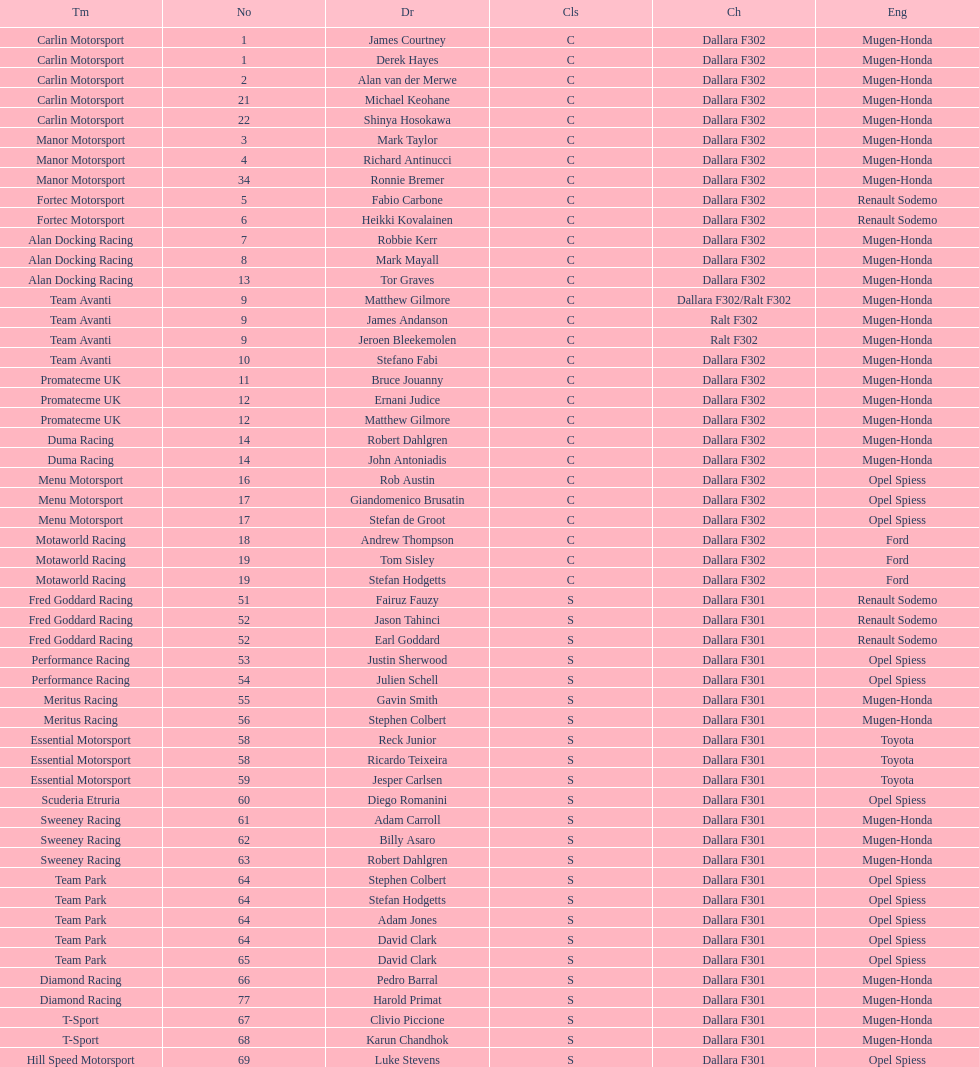Would you mind parsing the complete table? {'header': ['Tm', 'No', 'Dr', 'Cls', 'Ch', 'Eng'], 'rows': [['Carlin Motorsport', '1', 'James Courtney', 'C', 'Dallara F302', 'Mugen-Honda'], ['Carlin Motorsport', '1', 'Derek Hayes', 'C', 'Dallara F302', 'Mugen-Honda'], ['Carlin Motorsport', '2', 'Alan van der Merwe', 'C', 'Dallara F302', 'Mugen-Honda'], ['Carlin Motorsport', '21', 'Michael Keohane', 'C', 'Dallara F302', 'Mugen-Honda'], ['Carlin Motorsport', '22', 'Shinya Hosokawa', 'C', 'Dallara F302', 'Mugen-Honda'], ['Manor Motorsport', '3', 'Mark Taylor', 'C', 'Dallara F302', 'Mugen-Honda'], ['Manor Motorsport', '4', 'Richard Antinucci', 'C', 'Dallara F302', 'Mugen-Honda'], ['Manor Motorsport', '34', 'Ronnie Bremer', 'C', 'Dallara F302', 'Mugen-Honda'], ['Fortec Motorsport', '5', 'Fabio Carbone', 'C', 'Dallara F302', 'Renault Sodemo'], ['Fortec Motorsport', '6', 'Heikki Kovalainen', 'C', 'Dallara F302', 'Renault Sodemo'], ['Alan Docking Racing', '7', 'Robbie Kerr', 'C', 'Dallara F302', 'Mugen-Honda'], ['Alan Docking Racing', '8', 'Mark Mayall', 'C', 'Dallara F302', 'Mugen-Honda'], ['Alan Docking Racing', '13', 'Tor Graves', 'C', 'Dallara F302', 'Mugen-Honda'], ['Team Avanti', '9', 'Matthew Gilmore', 'C', 'Dallara F302/Ralt F302', 'Mugen-Honda'], ['Team Avanti', '9', 'James Andanson', 'C', 'Ralt F302', 'Mugen-Honda'], ['Team Avanti', '9', 'Jeroen Bleekemolen', 'C', 'Ralt F302', 'Mugen-Honda'], ['Team Avanti', '10', 'Stefano Fabi', 'C', 'Dallara F302', 'Mugen-Honda'], ['Promatecme UK', '11', 'Bruce Jouanny', 'C', 'Dallara F302', 'Mugen-Honda'], ['Promatecme UK', '12', 'Ernani Judice', 'C', 'Dallara F302', 'Mugen-Honda'], ['Promatecme UK', '12', 'Matthew Gilmore', 'C', 'Dallara F302', 'Mugen-Honda'], ['Duma Racing', '14', 'Robert Dahlgren', 'C', 'Dallara F302', 'Mugen-Honda'], ['Duma Racing', '14', 'John Antoniadis', 'C', 'Dallara F302', 'Mugen-Honda'], ['Menu Motorsport', '16', 'Rob Austin', 'C', 'Dallara F302', 'Opel Spiess'], ['Menu Motorsport', '17', 'Giandomenico Brusatin', 'C', 'Dallara F302', 'Opel Spiess'], ['Menu Motorsport', '17', 'Stefan de Groot', 'C', 'Dallara F302', 'Opel Spiess'], ['Motaworld Racing', '18', 'Andrew Thompson', 'C', 'Dallara F302', 'Ford'], ['Motaworld Racing', '19', 'Tom Sisley', 'C', 'Dallara F302', 'Ford'], ['Motaworld Racing', '19', 'Stefan Hodgetts', 'C', 'Dallara F302', 'Ford'], ['Fred Goddard Racing', '51', 'Fairuz Fauzy', 'S', 'Dallara F301', 'Renault Sodemo'], ['Fred Goddard Racing', '52', 'Jason Tahinci', 'S', 'Dallara F301', 'Renault Sodemo'], ['Fred Goddard Racing', '52', 'Earl Goddard', 'S', 'Dallara F301', 'Renault Sodemo'], ['Performance Racing', '53', 'Justin Sherwood', 'S', 'Dallara F301', 'Opel Spiess'], ['Performance Racing', '54', 'Julien Schell', 'S', 'Dallara F301', 'Opel Spiess'], ['Meritus Racing', '55', 'Gavin Smith', 'S', 'Dallara F301', 'Mugen-Honda'], ['Meritus Racing', '56', 'Stephen Colbert', 'S', 'Dallara F301', 'Mugen-Honda'], ['Essential Motorsport', '58', 'Reck Junior', 'S', 'Dallara F301', 'Toyota'], ['Essential Motorsport', '58', 'Ricardo Teixeira', 'S', 'Dallara F301', 'Toyota'], ['Essential Motorsport', '59', 'Jesper Carlsen', 'S', 'Dallara F301', 'Toyota'], ['Scuderia Etruria', '60', 'Diego Romanini', 'S', 'Dallara F301', 'Opel Spiess'], ['Sweeney Racing', '61', 'Adam Carroll', 'S', 'Dallara F301', 'Mugen-Honda'], ['Sweeney Racing', '62', 'Billy Asaro', 'S', 'Dallara F301', 'Mugen-Honda'], ['Sweeney Racing', '63', 'Robert Dahlgren', 'S', 'Dallara F301', 'Mugen-Honda'], ['Team Park', '64', 'Stephen Colbert', 'S', 'Dallara F301', 'Opel Spiess'], ['Team Park', '64', 'Stefan Hodgetts', 'S', 'Dallara F301', 'Opel Spiess'], ['Team Park', '64', 'Adam Jones', 'S', 'Dallara F301', 'Opel Spiess'], ['Team Park', '64', 'David Clark', 'S', 'Dallara F301', 'Opel Spiess'], ['Team Park', '65', 'David Clark', 'S', 'Dallara F301', 'Opel Spiess'], ['Diamond Racing', '66', 'Pedro Barral', 'S', 'Dallara F301', 'Mugen-Honda'], ['Diamond Racing', '77', 'Harold Primat', 'S', 'Dallara F301', 'Mugen-Honda'], ['T-Sport', '67', 'Clivio Piccione', 'S', 'Dallara F301', 'Mugen-Honda'], ['T-Sport', '68', 'Karun Chandhok', 'S', 'Dallara F301', 'Mugen-Honda'], ['Hill Speed Motorsport', '69', 'Luke Stevens', 'S', 'Dallara F301', 'Opel Spiess']]} What team is listed above diamond racing? Team Park. 